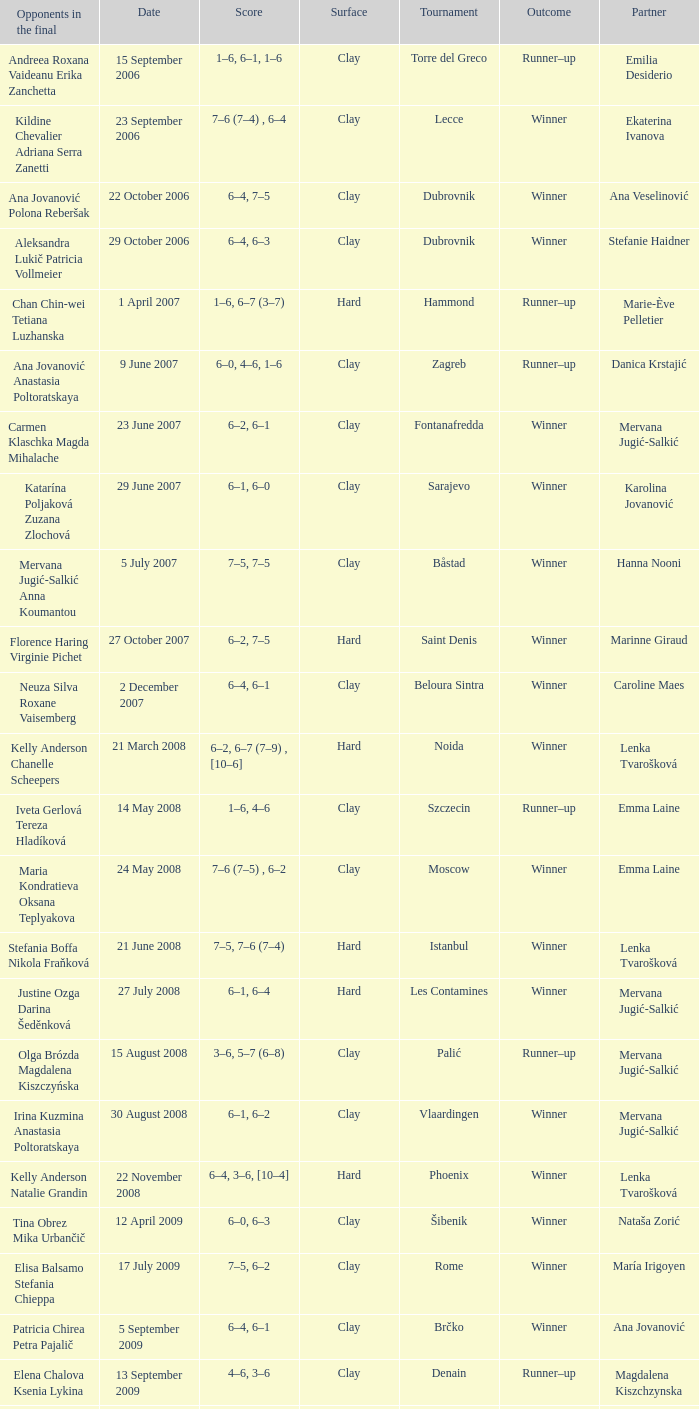Who were the opponents in the final at Noida? Kelly Anderson Chanelle Scheepers. 